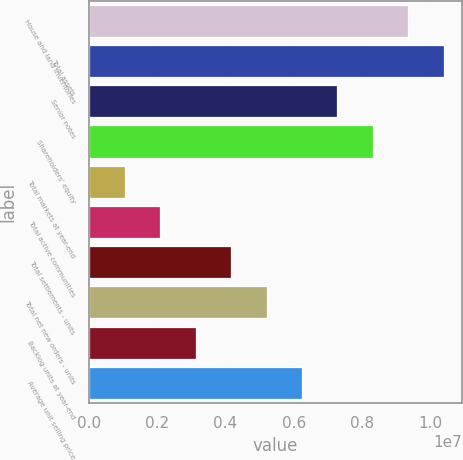<chart> <loc_0><loc_0><loc_500><loc_500><bar_chart><fcel>House and land inventories<fcel>Total assets<fcel>Senior notes<fcel>Shareholders' equity<fcel>Total markets at year-end<fcel>Total active communities<fcel>Total settlements - units<fcel>Total net new orders - units<fcel>Backlog units at year-end<fcel>Average unit selling price<nl><fcel>9.36621e+06<fcel>1.04069e+07<fcel>7.28483e+06<fcel>8.32552e+06<fcel>1.04071e+06<fcel>2.0814e+06<fcel>4.16277e+06<fcel>5.20346e+06<fcel>3.12208e+06<fcel>6.24415e+06<nl></chart> 